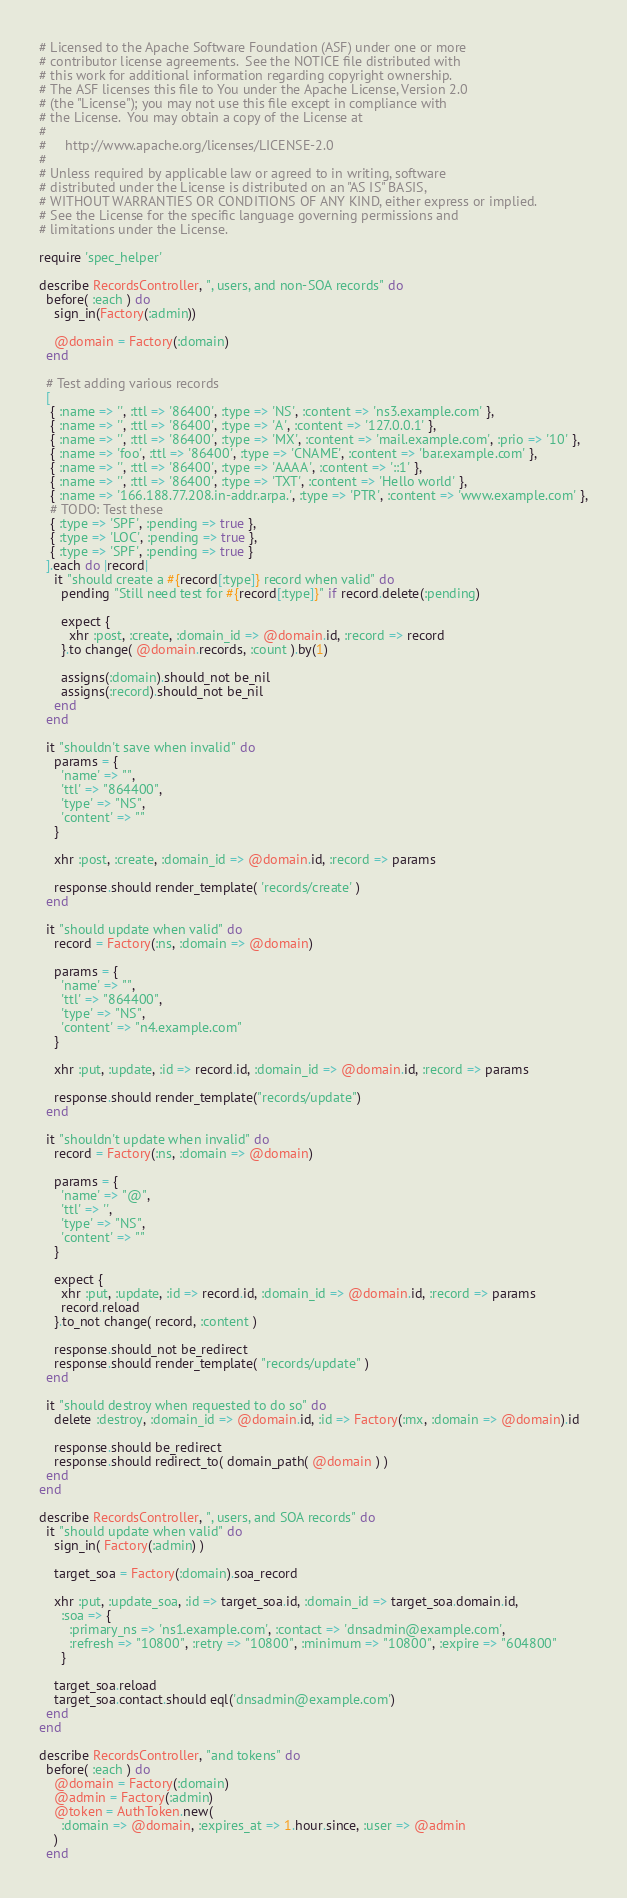Convert code to text. <code><loc_0><loc_0><loc_500><loc_500><_Ruby_># Licensed to the Apache Software Foundation (ASF) under one or more
# contributor license agreements.  See the NOTICE file distributed with
# this work for additional information regarding copyright ownership.
# The ASF licenses this file to You under the Apache License, Version 2.0
# (the "License"); you may not use this file except in compliance with
# the License.  You may obtain a copy of the License at
#
#     http://www.apache.org/licenses/LICENSE-2.0
#
# Unless required by applicable law or agreed to in writing, software
# distributed under the License is distributed on an "AS IS" BASIS,
# WITHOUT WARRANTIES OR CONDITIONS OF ANY KIND, either express or implied.
# See the License for the specific language governing permissions and
# limitations under the License.

require 'spec_helper'

describe RecordsController, ", users, and non-SOA records" do
  before( :each ) do
    sign_in(Factory(:admin))

    @domain = Factory(:domain)
  end

  # Test adding various records
  [
   { :name => '', :ttl => '86400', :type => 'NS', :content => 'ns3.example.com' },
   { :name => '', :ttl => '86400', :type => 'A', :content => '127.0.0.1' },
   { :name => '', :ttl => '86400', :type => 'MX', :content => 'mail.example.com', :prio => '10' },
   { :name => 'foo', :ttl => '86400', :type => 'CNAME', :content => 'bar.example.com' },
   { :name => '', :ttl => '86400', :type => 'AAAA', :content => '::1' },
   { :name => '', :ttl => '86400', :type => 'TXT', :content => 'Hello world' },
   { :name => '166.188.77.208.in-addr.arpa.', :type => 'PTR', :content => 'www.example.com' },
   # TODO: Test these
   { :type => 'SPF', :pending => true },
   { :type => 'LOC', :pending => true },
   { :type => 'SPF', :pending => true }
  ].each do |record|
    it "should create a #{record[:type]} record when valid" do
      pending "Still need test for #{record[:type]}" if record.delete(:pending)

      expect {
        xhr :post, :create, :domain_id => @domain.id, :record => record
      }.to change( @domain.records, :count ).by(1)

      assigns(:domain).should_not be_nil
      assigns(:record).should_not be_nil
    end
  end

  it "shouldn't save when invalid" do
    params = {
      'name' => "",
      'ttl' => "864400",
      'type' => "NS",
      'content' => ""
    }

    xhr :post, :create, :domain_id => @domain.id, :record => params

    response.should render_template( 'records/create' )
  end

  it "should update when valid" do
    record = Factory(:ns, :domain => @domain)

    params = {
      'name' => "",
      'ttl' => "864400",
      'type' => "NS",
      'content' => "n4.example.com"
    }

    xhr :put, :update, :id => record.id, :domain_id => @domain.id, :record => params

    response.should render_template("records/update")
  end

  it "shouldn't update when invalid" do
    record = Factory(:ns, :domain => @domain)

    params = {
      'name' => "@",
      'ttl' => '',
      'type' => "NS",
      'content' => ""
    }

    expect {
      xhr :put, :update, :id => record.id, :domain_id => @domain.id, :record => params
      record.reload
    }.to_not change( record, :content )

    response.should_not be_redirect
    response.should render_template( "records/update" )
  end

  it "should destroy when requested to do so" do
    delete :destroy, :domain_id => @domain.id, :id => Factory(:mx, :domain => @domain).id

    response.should be_redirect
    response.should redirect_to( domain_path( @domain ) )
  end
end

describe RecordsController, ", users, and SOA records" do
  it "should update when valid" do
    sign_in( Factory(:admin) )

    target_soa = Factory(:domain).soa_record

    xhr :put, :update_soa, :id => target_soa.id, :domain_id => target_soa.domain.id,
      :soa => {
        :primary_ns => 'ns1.example.com', :contact => 'dnsadmin@example.com',
        :refresh => "10800", :retry => "10800", :minimum => "10800", :expire => "604800"
      }

    target_soa.reload
    target_soa.contact.should eql('dnsadmin@example.com')
  end
end

describe RecordsController, "and tokens" do
  before( :each ) do
    @domain = Factory(:domain)
    @admin = Factory(:admin)
    @token = AuthToken.new(
      :domain => @domain, :expires_at => 1.hour.since, :user => @admin
    )
  end
</code> 